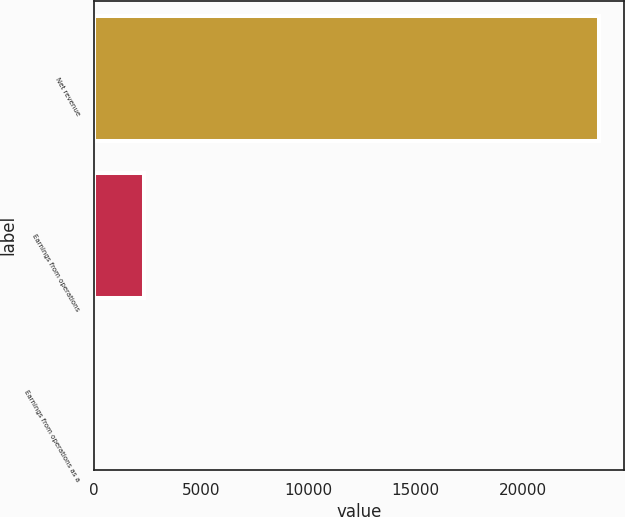Convert chart to OTSL. <chart><loc_0><loc_0><loc_500><loc_500><bar_chart><fcel>Net revenue<fcel>Earnings from operations<fcel>Earnings from operations as a<nl><fcel>23520<fcel>2354.61<fcel>2.9<nl></chart> 